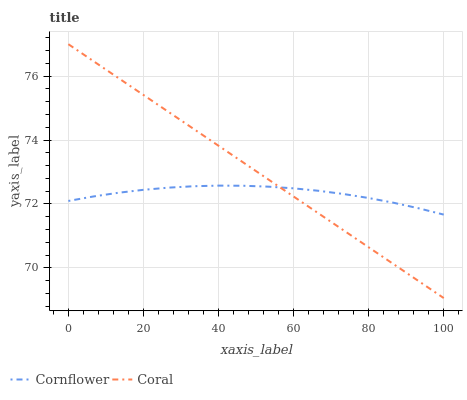Does Cornflower have the minimum area under the curve?
Answer yes or no. Yes. Does Coral have the maximum area under the curve?
Answer yes or no. Yes. Does Coral have the minimum area under the curve?
Answer yes or no. No. Is Coral the smoothest?
Answer yes or no. Yes. Is Cornflower the roughest?
Answer yes or no. Yes. Is Coral the roughest?
Answer yes or no. No. Does Coral have the lowest value?
Answer yes or no. Yes. Does Coral have the highest value?
Answer yes or no. Yes. Does Coral intersect Cornflower?
Answer yes or no. Yes. Is Coral less than Cornflower?
Answer yes or no. No. Is Coral greater than Cornflower?
Answer yes or no. No. 